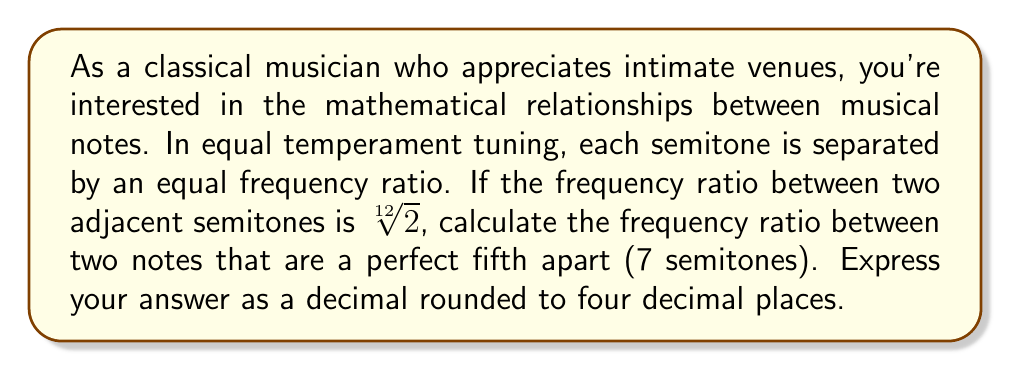Show me your answer to this math problem. To solve this problem, let's follow these steps:

1) In equal temperament, each semitone is separated by a frequency ratio of $\sqrt[12]{2}$.

2) A perfect fifth is an interval that spans 7 semitones.

3) To find the frequency ratio of a perfect fifth, we need to multiply the semitone ratio by itself 7 times:

   $$(\sqrt[12]{2})^7$$

4) This can be simplified using the properties of exponents:

   $$(\sqrt[12]{2})^7 = 2^{\frac{7}{12}}$$

5) Now we need to calculate this value:

   $$2^{\frac{7}{12}} \approx 1.4983070768766815...$$

6) Rounding to four decimal places:

   $$2^{\frac{7}{12}} \approx 1.4983$$

This ratio means that the higher note of a perfect fifth has a frequency about 1.4983 times that of the lower note.
Answer: 1.4983 